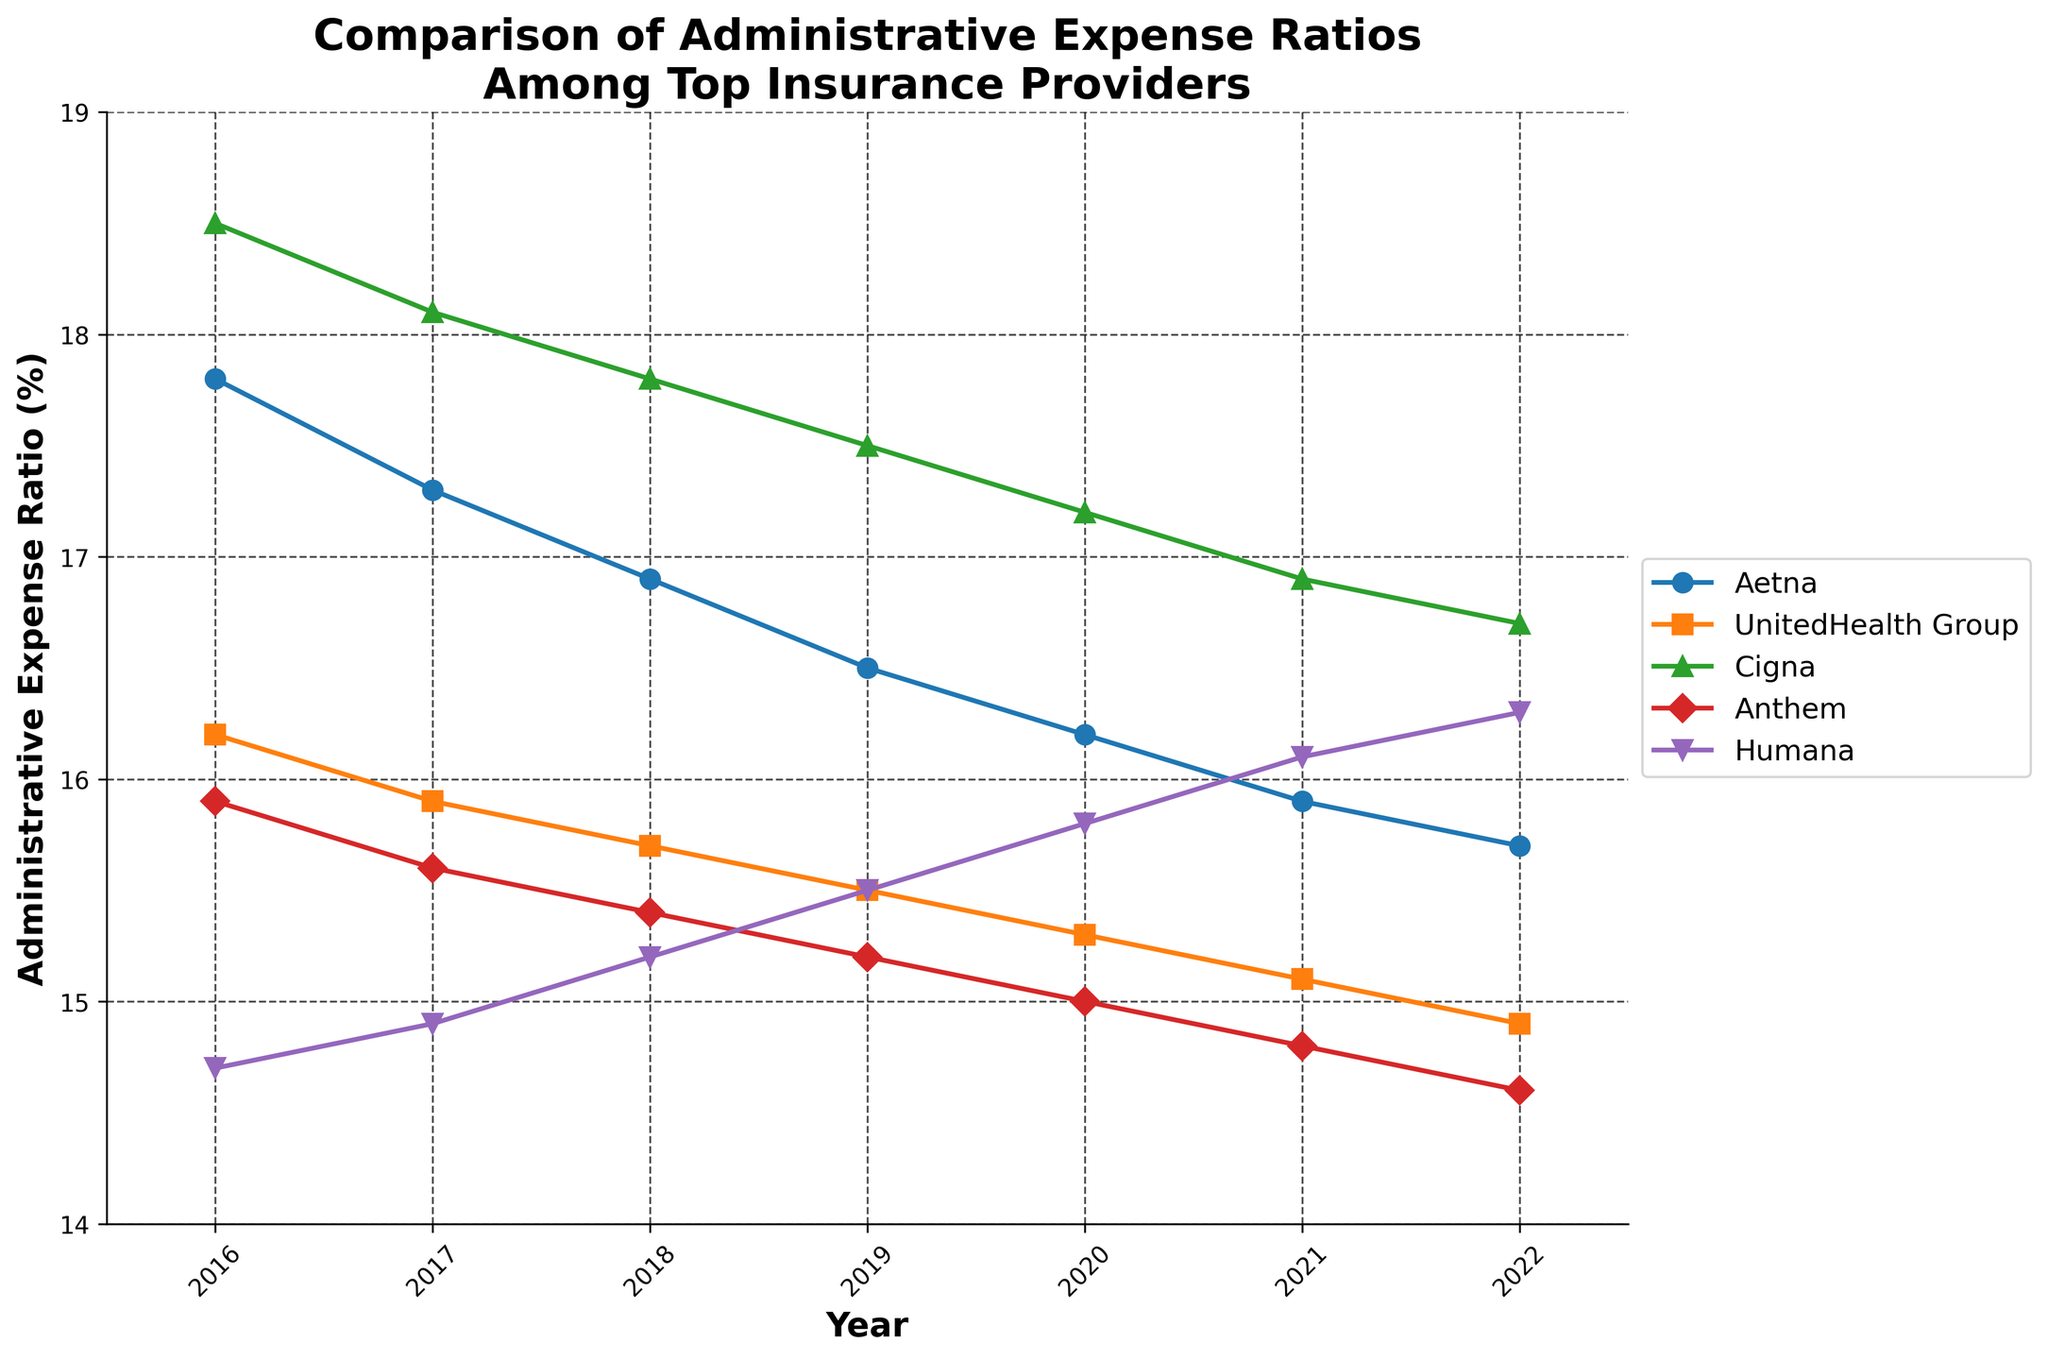Which insurance provider had the highest administrative expense ratio in 2022? From the figure, observe the lines at the 2022 mark and identify which one is highest. Cigna has the highest value.
Answer: Cigna How did Humana's administrative expense ratio change from 2016 to 2022? Check the values for Humana at 2016 and 2022. In 2016 it was 14.7%, and in 2022 it was 16.3%. Calculate the difference, 16.3% - 14.7% = 1.6%.
Answer: It increased by 1.6% Which insurance provider had the most significant drop in the administrative expense ratio from 2016 to 2022? Calculate the change in ratios for each provider from 2016 to 2022. Aetna's drop is (17.8% - 15.7%) = 2.1%, UnitedHealth Group's drop is (16.2% - 14.9%) = 1.3%, Cigna's drop is (18.5% - 16.7%) = 1.8%, Anthem's drop is (15.9% - 14.6%) = 1.3%, and Humana's increase is skipped. The largest drop is for Aetna.
Answer: Aetna Compare the administrative expense ratios between Aetna and UnitedHealth Group in 2020. Which had a lower ratio? Look at the values for Aetna and UnitedHealth Group in 2020. Aetna: 16.2%, UnitedHealth Group: 15.3%. Compare the values directly.
Answer: UnitedHealth Group What is the average administrative expense ratio for Anthem over the given years? Sum the values for Anthem from 2016 to 2022 and divide by the number of years. (15.9 + 15.6 + 15.4 + 15.2 + 15.0 + 14.8 + 14.6) / 7 = 15.21%.
Answer: 15.21% Which year did Cigna show its highest administrative expense ratio? By looking at Cigna's line, find the highest point which occurs in 2016 at 18.5%.
Answer: 2016 In which year did Aetna and Humana have the same administrative expense ratio? Identify the year where the lines for Aetna and Humana intersect or are very close. No such intersection occurs from the data between 2016 to 2022 as per the provided values.
Answer: No year How many insurance providers had an administrative expense ratio below 16% in 2021? Identify which providers had ratios below 16% in 2021. UnitedHealth Group (15.1%), Anthem (14.8%), and Humana (16.1% is not below 16%). In total, two providers.
Answer: Two What is the sum of administrative expense ratios of all providers in 2019? Add the values for each provider in 2019. (16.5 + 15.5 + 17.5 + 15.2 + 15.5) = 80.2%.
Answer: 80.2% 